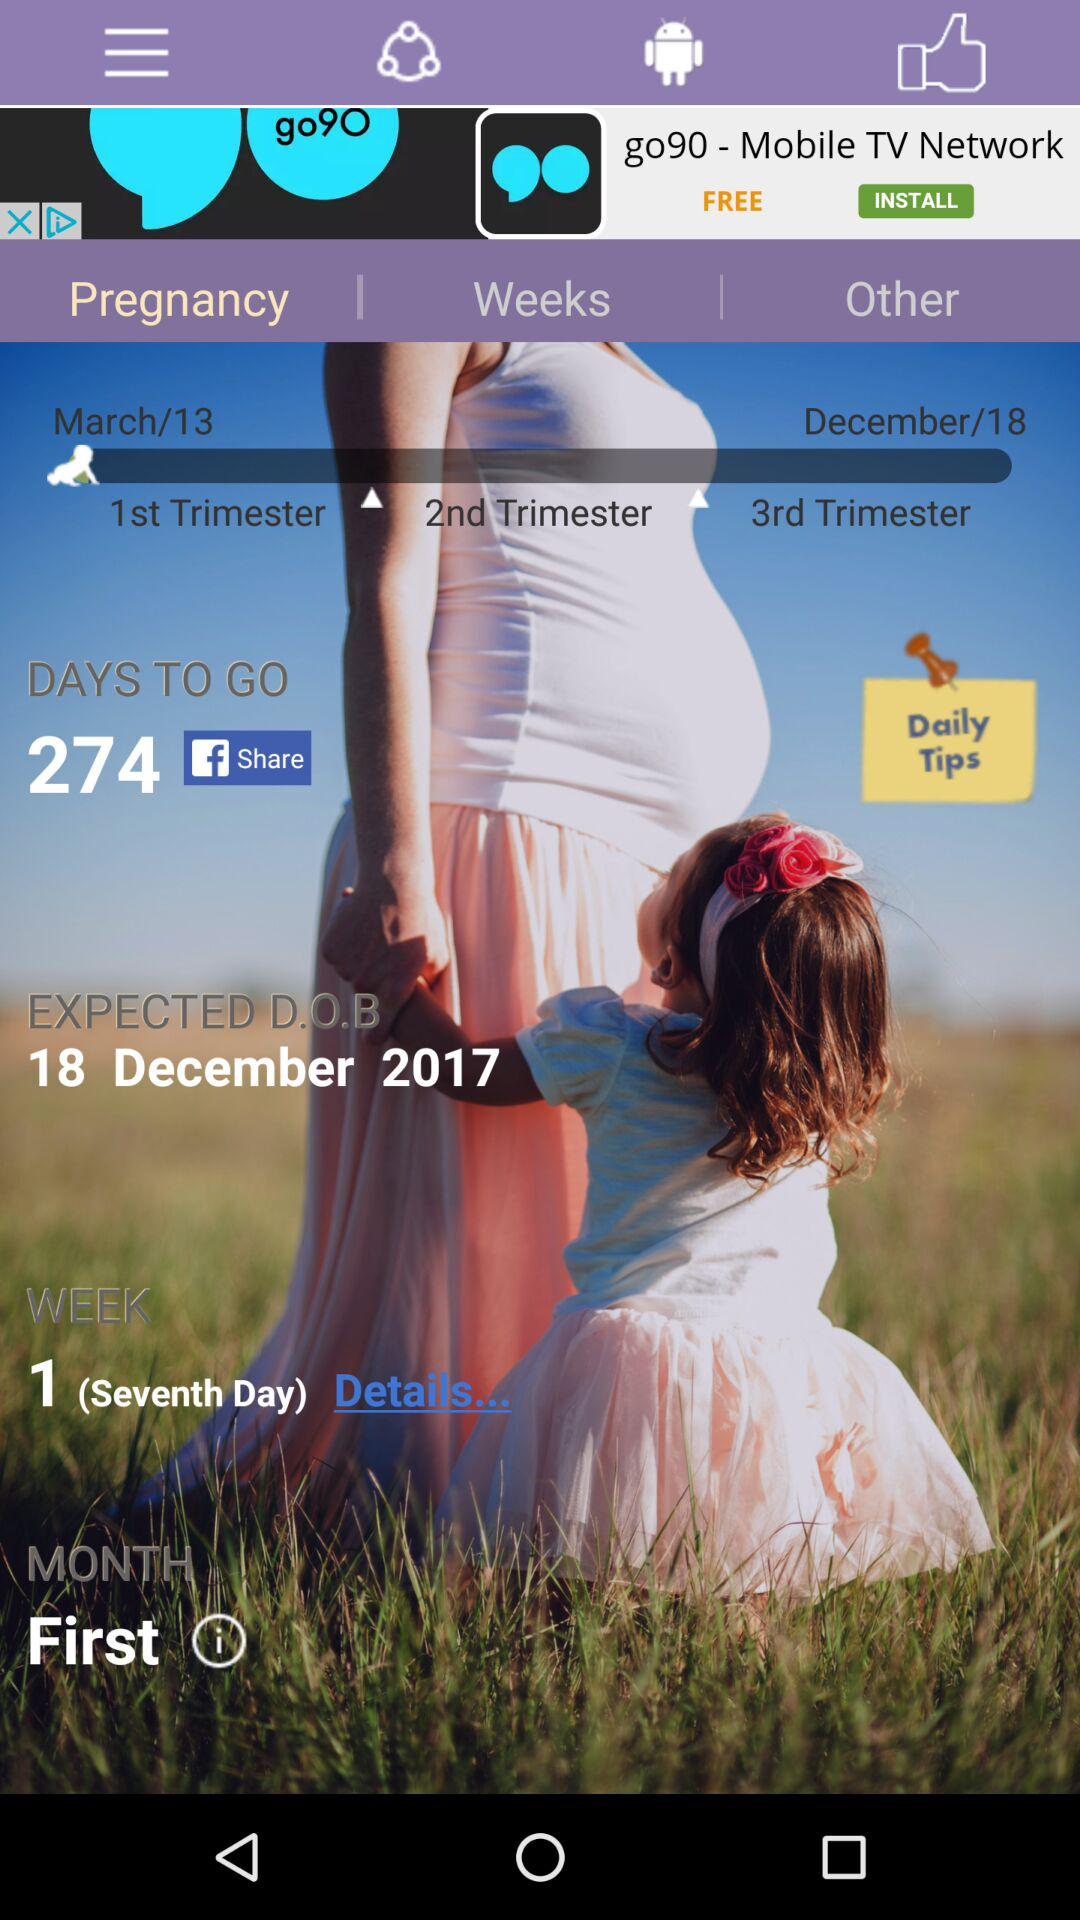What is the expected due date?
Answer the question using a single word or phrase. 18 December 2017 